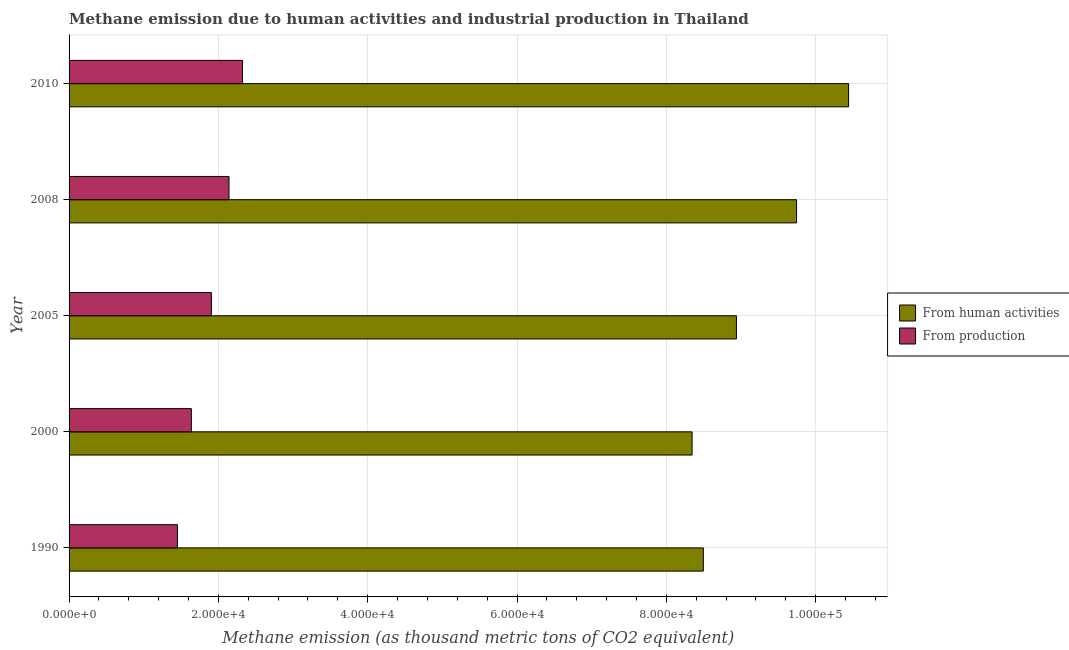Are the number of bars per tick equal to the number of legend labels?
Keep it short and to the point. Yes. Are the number of bars on each tick of the Y-axis equal?
Make the answer very short. Yes. How many bars are there on the 5th tick from the top?
Your answer should be compact. 2. How many bars are there on the 3rd tick from the bottom?
Give a very brief answer. 2. What is the label of the 5th group of bars from the top?
Provide a succinct answer. 1990. What is the amount of emissions from human activities in 2005?
Offer a very short reply. 8.94e+04. Across all years, what is the maximum amount of emissions from human activities?
Ensure brevity in your answer.  1.04e+05. Across all years, what is the minimum amount of emissions from human activities?
Ensure brevity in your answer.  8.34e+04. In which year was the amount of emissions generated from industries maximum?
Your response must be concise. 2010. In which year was the amount of emissions generated from industries minimum?
Make the answer very short. 1990. What is the total amount of emissions generated from industries in the graph?
Ensure brevity in your answer.  9.46e+04. What is the difference between the amount of emissions generated from industries in 1990 and that in 2005?
Your answer should be compact. -4546.4. What is the difference between the amount of emissions generated from industries in 2000 and the amount of emissions from human activities in 2005?
Your answer should be compact. -7.30e+04. What is the average amount of emissions generated from industries per year?
Ensure brevity in your answer.  1.89e+04. In the year 2010, what is the difference between the amount of emissions generated from industries and amount of emissions from human activities?
Your answer should be very brief. -8.12e+04. Is the amount of emissions from human activities in 2000 less than that in 2010?
Provide a short and direct response. Yes. What is the difference between the highest and the second highest amount of emissions generated from industries?
Make the answer very short. 1813.8. What is the difference between the highest and the lowest amount of emissions from human activities?
Provide a short and direct response. 2.10e+04. In how many years, is the amount of emissions from human activities greater than the average amount of emissions from human activities taken over all years?
Your response must be concise. 2. Is the sum of the amount of emissions from human activities in 2000 and 2005 greater than the maximum amount of emissions generated from industries across all years?
Provide a succinct answer. Yes. What does the 1st bar from the top in 2010 represents?
Your answer should be very brief. From production. What does the 2nd bar from the bottom in 2005 represents?
Ensure brevity in your answer.  From production. How many bars are there?
Offer a very short reply. 10. Are all the bars in the graph horizontal?
Your answer should be very brief. Yes. How many years are there in the graph?
Provide a succinct answer. 5. What is the difference between two consecutive major ticks on the X-axis?
Make the answer very short. 2.00e+04. Does the graph contain any zero values?
Provide a succinct answer. No. What is the title of the graph?
Your answer should be compact. Methane emission due to human activities and industrial production in Thailand. Does "National Tourists" appear as one of the legend labels in the graph?
Your answer should be compact. No. What is the label or title of the X-axis?
Keep it short and to the point. Methane emission (as thousand metric tons of CO2 equivalent). What is the label or title of the Y-axis?
Your answer should be compact. Year. What is the Methane emission (as thousand metric tons of CO2 equivalent) in From human activities in 1990?
Provide a short and direct response. 8.50e+04. What is the Methane emission (as thousand metric tons of CO2 equivalent) in From production in 1990?
Ensure brevity in your answer.  1.45e+04. What is the Methane emission (as thousand metric tons of CO2 equivalent) of From human activities in 2000?
Keep it short and to the point. 8.34e+04. What is the Methane emission (as thousand metric tons of CO2 equivalent) in From production in 2000?
Provide a succinct answer. 1.64e+04. What is the Methane emission (as thousand metric tons of CO2 equivalent) in From human activities in 2005?
Your response must be concise. 8.94e+04. What is the Methane emission (as thousand metric tons of CO2 equivalent) of From production in 2005?
Ensure brevity in your answer.  1.91e+04. What is the Methane emission (as thousand metric tons of CO2 equivalent) of From human activities in 2008?
Give a very brief answer. 9.74e+04. What is the Methane emission (as thousand metric tons of CO2 equivalent) of From production in 2008?
Keep it short and to the point. 2.14e+04. What is the Methane emission (as thousand metric tons of CO2 equivalent) of From human activities in 2010?
Make the answer very short. 1.04e+05. What is the Methane emission (as thousand metric tons of CO2 equivalent) in From production in 2010?
Give a very brief answer. 2.32e+04. Across all years, what is the maximum Methane emission (as thousand metric tons of CO2 equivalent) in From human activities?
Your answer should be compact. 1.04e+05. Across all years, what is the maximum Methane emission (as thousand metric tons of CO2 equivalent) in From production?
Your answer should be very brief. 2.32e+04. Across all years, what is the minimum Methane emission (as thousand metric tons of CO2 equivalent) in From human activities?
Your response must be concise. 8.34e+04. Across all years, what is the minimum Methane emission (as thousand metric tons of CO2 equivalent) in From production?
Make the answer very short. 1.45e+04. What is the total Methane emission (as thousand metric tons of CO2 equivalent) in From human activities in the graph?
Ensure brevity in your answer.  4.60e+05. What is the total Methane emission (as thousand metric tons of CO2 equivalent) of From production in the graph?
Provide a succinct answer. 9.46e+04. What is the difference between the Methane emission (as thousand metric tons of CO2 equivalent) in From human activities in 1990 and that in 2000?
Provide a short and direct response. 1507.2. What is the difference between the Methane emission (as thousand metric tons of CO2 equivalent) of From production in 1990 and that in 2000?
Your answer should be very brief. -1865.4. What is the difference between the Methane emission (as thousand metric tons of CO2 equivalent) of From human activities in 1990 and that in 2005?
Offer a terse response. -4432.2. What is the difference between the Methane emission (as thousand metric tons of CO2 equivalent) of From production in 1990 and that in 2005?
Make the answer very short. -4546.4. What is the difference between the Methane emission (as thousand metric tons of CO2 equivalent) of From human activities in 1990 and that in 2008?
Keep it short and to the point. -1.25e+04. What is the difference between the Methane emission (as thousand metric tons of CO2 equivalent) in From production in 1990 and that in 2008?
Your response must be concise. -6904.8. What is the difference between the Methane emission (as thousand metric tons of CO2 equivalent) of From human activities in 1990 and that in 2010?
Ensure brevity in your answer.  -1.95e+04. What is the difference between the Methane emission (as thousand metric tons of CO2 equivalent) in From production in 1990 and that in 2010?
Make the answer very short. -8718.6. What is the difference between the Methane emission (as thousand metric tons of CO2 equivalent) of From human activities in 2000 and that in 2005?
Provide a succinct answer. -5939.4. What is the difference between the Methane emission (as thousand metric tons of CO2 equivalent) in From production in 2000 and that in 2005?
Your answer should be compact. -2681. What is the difference between the Methane emission (as thousand metric tons of CO2 equivalent) in From human activities in 2000 and that in 2008?
Ensure brevity in your answer.  -1.40e+04. What is the difference between the Methane emission (as thousand metric tons of CO2 equivalent) of From production in 2000 and that in 2008?
Your response must be concise. -5039.4. What is the difference between the Methane emission (as thousand metric tons of CO2 equivalent) of From human activities in 2000 and that in 2010?
Your answer should be compact. -2.10e+04. What is the difference between the Methane emission (as thousand metric tons of CO2 equivalent) in From production in 2000 and that in 2010?
Ensure brevity in your answer.  -6853.2. What is the difference between the Methane emission (as thousand metric tons of CO2 equivalent) of From human activities in 2005 and that in 2008?
Your answer should be compact. -8056. What is the difference between the Methane emission (as thousand metric tons of CO2 equivalent) in From production in 2005 and that in 2008?
Provide a succinct answer. -2358.4. What is the difference between the Methane emission (as thousand metric tons of CO2 equivalent) of From human activities in 2005 and that in 2010?
Your answer should be very brief. -1.50e+04. What is the difference between the Methane emission (as thousand metric tons of CO2 equivalent) of From production in 2005 and that in 2010?
Offer a terse response. -4172.2. What is the difference between the Methane emission (as thousand metric tons of CO2 equivalent) of From human activities in 2008 and that in 2010?
Offer a terse response. -6966.7. What is the difference between the Methane emission (as thousand metric tons of CO2 equivalent) of From production in 2008 and that in 2010?
Your answer should be compact. -1813.8. What is the difference between the Methane emission (as thousand metric tons of CO2 equivalent) of From human activities in 1990 and the Methane emission (as thousand metric tons of CO2 equivalent) of From production in 2000?
Ensure brevity in your answer.  6.86e+04. What is the difference between the Methane emission (as thousand metric tons of CO2 equivalent) of From human activities in 1990 and the Methane emission (as thousand metric tons of CO2 equivalent) of From production in 2005?
Keep it short and to the point. 6.59e+04. What is the difference between the Methane emission (as thousand metric tons of CO2 equivalent) of From human activities in 1990 and the Methane emission (as thousand metric tons of CO2 equivalent) of From production in 2008?
Provide a short and direct response. 6.35e+04. What is the difference between the Methane emission (as thousand metric tons of CO2 equivalent) of From human activities in 1990 and the Methane emission (as thousand metric tons of CO2 equivalent) of From production in 2010?
Keep it short and to the point. 6.17e+04. What is the difference between the Methane emission (as thousand metric tons of CO2 equivalent) of From human activities in 2000 and the Methane emission (as thousand metric tons of CO2 equivalent) of From production in 2005?
Provide a short and direct response. 6.44e+04. What is the difference between the Methane emission (as thousand metric tons of CO2 equivalent) in From human activities in 2000 and the Methane emission (as thousand metric tons of CO2 equivalent) in From production in 2008?
Keep it short and to the point. 6.20e+04. What is the difference between the Methane emission (as thousand metric tons of CO2 equivalent) of From human activities in 2000 and the Methane emission (as thousand metric tons of CO2 equivalent) of From production in 2010?
Provide a succinct answer. 6.02e+04. What is the difference between the Methane emission (as thousand metric tons of CO2 equivalent) of From human activities in 2005 and the Methane emission (as thousand metric tons of CO2 equivalent) of From production in 2008?
Offer a terse response. 6.80e+04. What is the difference between the Methane emission (as thousand metric tons of CO2 equivalent) of From human activities in 2005 and the Methane emission (as thousand metric tons of CO2 equivalent) of From production in 2010?
Give a very brief answer. 6.62e+04. What is the difference between the Methane emission (as thousand metric tons of CO2 equivalent) in From human activities in 2008 and the Methane emission (as thousand metric tons of CO2 equivalent) in From production in 2010?
Your answer should be compact. 7.42e+04. What is the average Methane emission (as thousand metric tons of CO2 equivalent) of From human activities per year?
Ensure brevity in your answer.  9.19e+04. What is the average Methane emission (as thousand metric tons of CO2 equivalent) of From production per year?
Your response must be concise. 1.89e+04. In the year 1990, what is the difference between the Methane emission (as thousand metric tons of CO2 equivalent) of From human activities and Methane emission (as thousand metric tons of CO2 equivalent) of From production?
Provide a succinct answer. 7.04e+04. In the year 2000, what is the difference between the Methane emission (as thousand metric tons of CO2 equivalent) in From human activities and Methane emission (as thousand metric tons of CO2 equivalent) in From production?
Keep it short and to the point. 6.71e+04. In the year 2005, what is the difference between the Methane emission (as thousand metric tons of CO2 equivalent) of From human activities and Methane emission (as thousand metric tons of CO2 equivalent) of From production?
Provide a short and direct response. 7.03e+04. In the year 2008, what is the difference between the Methane emission (as thousand metric tons of CO2 equivalent) in From human activities and Methane emission (as thousand metric tons of CO2 equivalent) in From production?
Make the answer very short. 7.60e+04. In the year 2010, what is the difference between the Methane emission (as thousand metric tons of CO2 equivalent) in From human activities and Methane emission (as thousand metric tons of CO2 equivalent) in From production?
Provide a short and direct response. 8.12e+04. What is the ratio of the Methane emission (as thousand metric tons of CO2 equivalent) in From human activities in 1990 to that in 2000?
Your answer should be compact. 1.02. What is the ratio of the Methane emission (as thousand metric tons of CO2 equivalent) in From production in 1990 to that in 2000?
Provide a succinct answer. 0.89. What is the ratio of the Methane emission (as thousand metric tons of CO2 equivalent) of From human activities in 1990 to that in 2005?
Make the answer very short. 0.95. What is the ratio of the Methane emission (as thousand metric tons of CO2 equivalent) of From production in 1990 to that in 2005?
Your answer should be very brief. 0.76. What is the ratio of the Methane emission (as thousand metric tons of CO2 equivalent) in From human activities in 1990 to that in 2008?
Ensure brevity in your answer.  0.87. What is the ratio of the Methane emission (as thousand metric tons of CO2 equivalent) in From production in 1990 to that in 2008?
Your answer should be compact. 0.68. What is the ratio of the Methane emission (as thousand metric tons of CO2 equivalent) of From human activities in 1990 to that in 2010?
Your answer should be compact. 0.81. What is the ratio of the Methane emission (as thousand metric tons of CO2 equivalent) in From production in 1990 to that in 2010?
Ensure brevity in your answer.  0.62. What is the ratio of the Methane emission (as thousand metric tons of CO2 equivalent) in From human activities in 2000 to that in 2005?
Keep it short and to the point. 0.93. What is the ratio of the Methane emission (as thousand metric tons of CO2 equivalent) in From production in 2000 to that in 2005?
Keep it short and to the point. 0.86. What is the ratio of the Methane emission (as thousand metric tons of CO2 equivalent) of From human activities in 2000 to that in 2008?
Ensure brevity in your answer.  0.86. What is the ratio of the Methane emission (as thousand metric tons of CO2 equivalent) of From production in 2000 to that in 2008?
Offer a very short reply. 0.76. What is the ratio of the Methane emission (as thousand metric tons of CO2 equivalent) in From human activities in 2000 to that in 2010?
Provide a succinct answer. 0.8. What is the ratio of the Methane emission (as thousand metric tons of CO2 equivalent) in From production in 2000 to that in 2010?
Give a very brief answer. 0.7. What is the ratio of the Methane emission (as thousand metric tons of CO2 equivalent) in From human activities in 2005 to that in 2008?
Your response must be concise. 0.92. What is the ratio of the Methane emission (as thousand metric tons of CO2 equivalent) in From production in 2005 to that in 2008?
Your answer should be very brief. 0.89. What is the ratio of the Methane emission (as thousand metric tons of CO2 equivalent) of From human activities in 2005 to that in 2010?
Offer a terse response. 0.86. What is the ratio of the Methane emission (as thousand metric tons of CO2 equivalent) in From production in 2005 to that in 2010?
Keep it short and to the point. 0.82. What is the ratio of the Methane emission (as thousand metric tons of CO2 equivalent) of From human activities in 2008 to that in 2010?
Your response must be concise. 0.93. What is the ratio of the Methane emission (as thousand metric tons of CO2 equivalent) of From production in 2008 to that in 2010?
Your answer should be very brief. 0.92. What is the difference between the highest and the second highest Methane emission (as thousand metric tons of CO2 equivalent) of From human activities?
Your answer should be very brief. 6966.7. What is the difference between the highest and the second highest Methane emission (as thousand metric tons of CO2 equivalent) of From production?
Your response must be concise. 1813.8. What is the difference between the highest and the lowest Methane emission (as thousand metric tons of CO2 equivalent) in From human activities?
Provide a succinct answer. 2.10e+04. What is the difference between the highest and the lowest Methane emission (as thousand metric tons of CO2 equivalent) in From production?
Make the answer very short. 8718.6. 